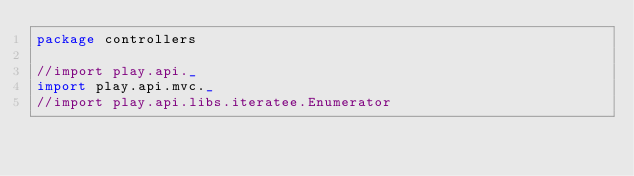<code> <loc_0><loc_0><loc_500><loc_500><_Scala_>package controllers

//import play.api._
import play.api.mvc._
//import play.api.libs.iteratee.Enumerator
</code> 